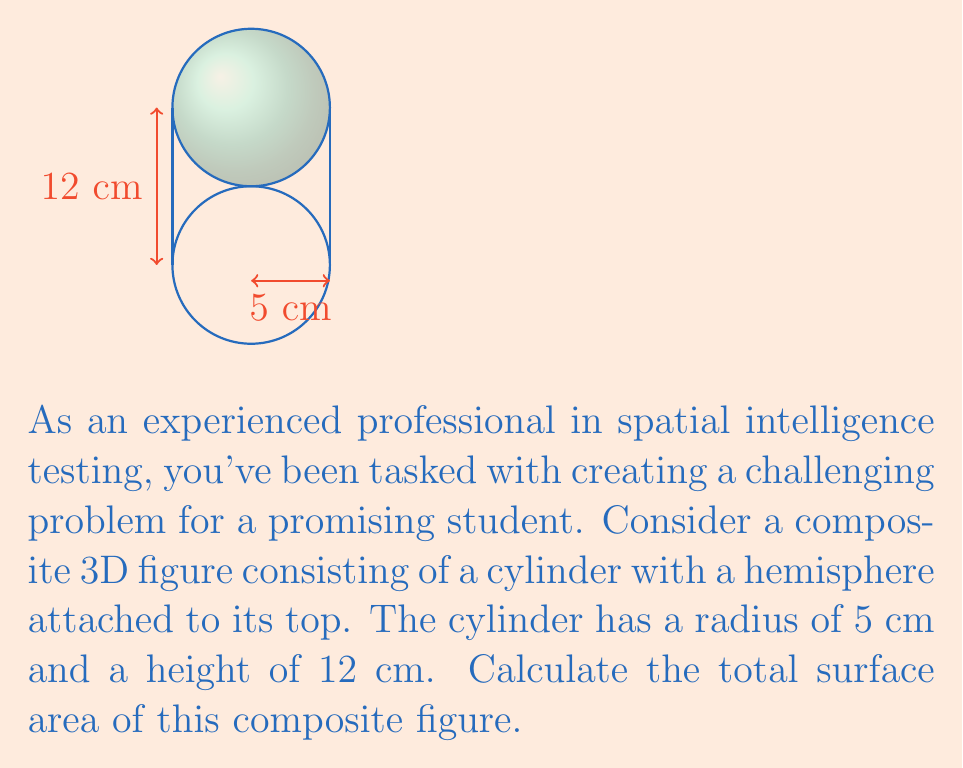Help me with this question. Let's approach this step-by-step:

1) The composite figure consists of two parts:
   a) A cylinder (without its top face)
   b) A hemisphere

2) For the cylinder:
   - Radius (r) = 5 cm
   - Height (h) = 12 cm
   - Surface area = lateral area (no top face)
   $$A_{cylinder} = 2\pi rh = 2\pi \cdot 5 \cdot 12 = 120\pi \text{ cm}^2$$

3) For the hemisphere:
   - Radius (r) = 5 cm
   - Surface area = area of a full sphere ÷ 2
   $$A_{hemisphere} = \frac{1}{2} \cdot 4\pi r^2 = 2\pi r^2 = 2\pi \cdot 5^2 = 50\pi \text{ cm}^2$$

4) The total surface area is the sum of these two parts:
   $$A_{total} = A_{cylinder} + A_{hemisphere} = 120\pi + 50\pi = 170\pi \text{ cm}^2$$

5) If we need to give a numerical value, we can approximate π to 3.14159:
   $$A_{total} \approx 170 \cdot 3.14159 \approx 534.07 \text{ cm}^2$$
Answer: $170\pi \text{ cm}^2$ or approximately $534.07 \text{ cm}^2$ 